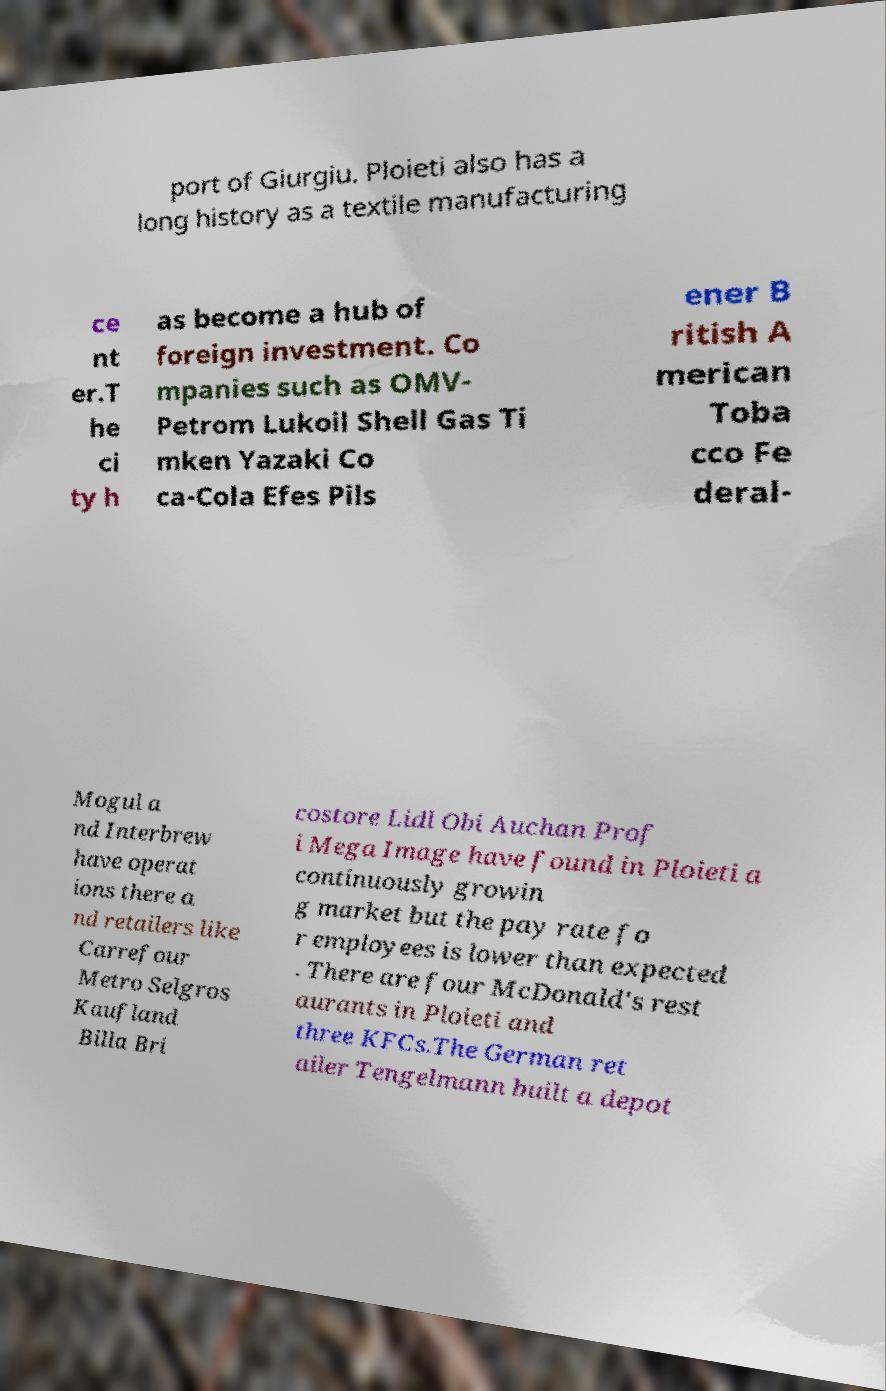What messages or text are displayed in this image? I need them in a readable, typed format. port of Giurgiu. Ploieti also has a long history as a textile manufacturing ce nt er.T he ci ty h as become a hub of foreign investment. Co mpanies such as OMV- Petrom Lukoil Shell Gas Ti mken Yazaki Co ca-Cola Efes Pils ener B ritish A merican Toba cco Fe deral- Mogul a nd Interbrew have operat ions there a nd retailers like Carrefour Metro Selgros Kaufland Billa Bri costore Lidl Obi Auchan Prof i Mega Image have found in Ploieti a continuously growin g market but the pay rate fo r employees is lower than expected . There are four McDonald's rest aurants in Ploieti and three KFCs.The German ret ailer Tengelmann built a depot 